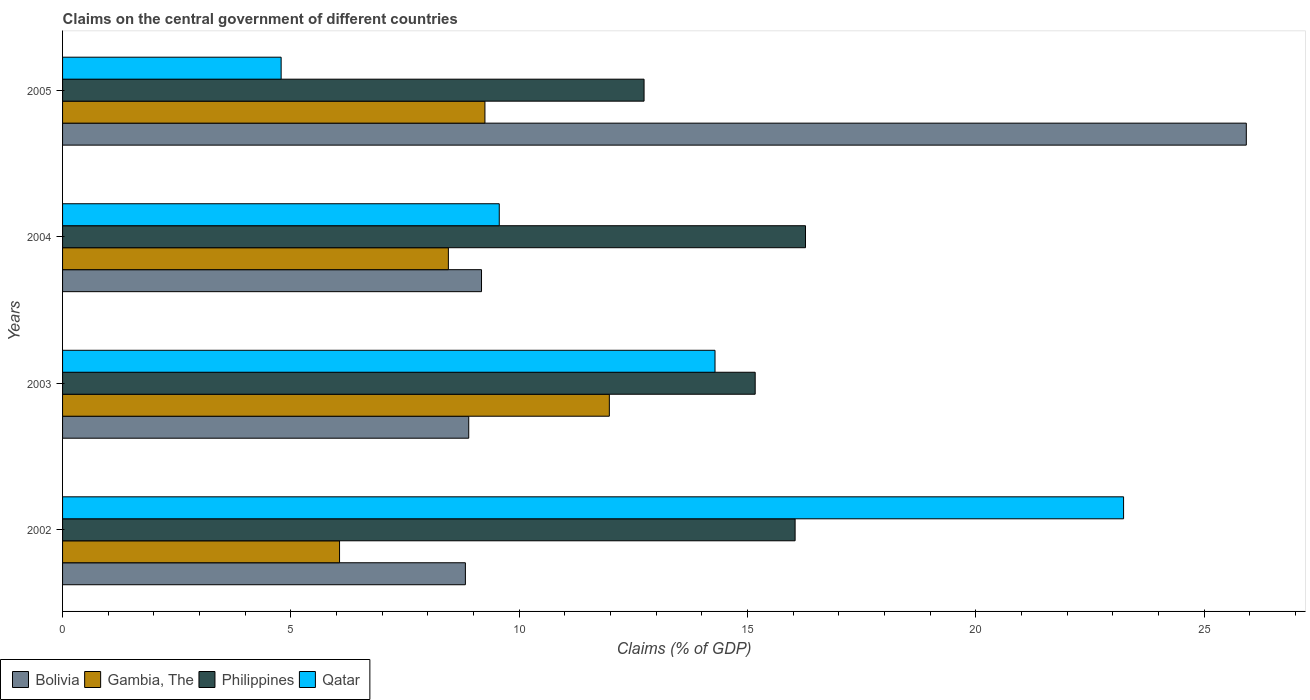How many different coloured bars are there?
Give a very brief answer. 4. Are the number of bars per tick equal to the number of legend labels?
Your answer should be compact. Yes. What is the label of the 3rd group of bars from the top?
Provide a succinct answer. 2003. In how many cases, is the number of bars for a given year not equal to the number of legend labels?
Make the answer very short. 0. What is the percentage of GDP claimed on the central government in Bolivia in 2005?
Keep it short and to the point. 25.92. Across all years, what is the maximum percentage of GDP claimed on the central government in Qatar?
Offer a very short reply. 23.23. Across all years, what is the minimum percentage of GDP claimed on the central government in Gambia, The?
Your answer should be compact. 6.07. In which year was the percentage of GDP claimed on the central government in Philippines maximum?
Provide a short and direct response. 2004. What is the total percentage of GDP claimed on the central government in Bolivia in the graph?
Ensure brevity in your answer.  52.81. What is the difference between the percentage of GDP claimed on the central government in Philippines in 2002 and that in 2005?
Make the answer very short. 3.31. What is the difference between the percentage of GDP claimed on the central government in Gambia, The in 2003 and the percentage of GDP claimed on the central government in Philippines in 2002?
Offer a very short reply. -4.07. What is the average percentage of GDP claimed on the central government in Bolivia per year?
Offer a terse response. 13.2. In the year 2005, what is the difference between the percentage of GDP claimed on the central government in Qatar and percentage of GDP claimed on the central government in Philippines?
Keep it short and to the point. -7.95. In how many years, is the percentage of GDP claimed on the central government in Gambia, The greater than 3 %?
Keep it short and to the point. 4. What is the ratio of the percentage of GDP claimed on the central government in Qatar in 2002 to that in 2004?
Offer a terse response. 2.43. What is the difference between the highest and the second highest percentage of GDP claimed on the central government in Gambia, The?
Offer a very short reply. 2.72. What is the difference between the highest and the lowest percentage of GDP claimed on the central government in Bolivia?
Your answer should be very brief. 17.1. Is the sum of the percentage of GDP claimed on the central government in Gambia, The in 2003 and 2005 greater than the maximum percentage of GDP claimed on the central government in Philippines across all years?
Make the answer very short. Yes. What does the 3rd bar from the top in 2005 represents?
Offer a very short reply. Gambia, The. How many bars are there?
Make the answer very short. 16. Are all the bars in the graph horizontal?
Offer a very short reply. Yes. Are the values on the major ticks of X-axis written in scientific E-notation?
Ensure brevity in your answer.  No. Does the graph contain any zero values?
Provide a short and direct response. No. Does the graph contain grids?
Give a very brief answer. No. Where does the legend appear in the graph?
Make the answer very short. Bottom left. What is the title of the graph?
Give a very brief answer. Claims on the central government of different countries. Does "Japan" appear as one of the legend labels in the graph?
Your answer should be very brief. No. What is the label or title of the X-axis?
Your response must be concise. Claims (% of GDP). What is the label or title of the Y-axis?
Make the answer very short. Years. What is the Claims (% of GDP) in Bolivia in 2002?
Provide a short and direct response. 8.82. What is the Claims (% of GDP) in Gambia, The in 2002?
Your answer should be compact. 6.07. What is the Claims (% of GDP) in Philippines in 2002?
Your answer should be very brief. 16.04. What is the Claims (% of GDP) in Qatar in 2002?
Give a very brief answer. 23.23. What is the Claims (% of GDP) in Bolivia in 2003?
Keep it short and to the point. 8.89. What is the Claims (% of GDP) of Gambia, The in 2003?
Your answer should be compact. 11.97. What is the Claims (% of GDP) in Philippines in 2003?
Keep it short and to the point. 15.17. What is the Claims (% of GDP) of Qatar in 2003?
Your answer should be compact. 14.29. What is the Claims (% of GDP) in Bolivia in 2004?
Provide a short and direct response. 9.17. What is the Claims (% of GDP) of Gambia, The in 2004?
Your answer should be very brief. 8.45. What is the Claims (% of GDP) of Philippines in 2004?
Provide a short and direct response. 16.27. What is the Claims (% of GDP) of Qatar in 2004?
Provide a short and direct response. 9.56. What is the Claims (% of GDP) of Bolivia in 2005?
Your answer should be very brief. 25.92. What is the Claims (% of GDP) of Gambia, The in 2005?
Make the answer very short. 9.25. What is the Claims (% of GDP) in Philippines in 2005?
Offer a terse response. 12.73. What is the Claims (% of GDP) of Qatar in 2005?
Provide a short and direct response. 4.79. Across all years, what is the maximum Claims (% of GDP) of Bolivia?
Your answer should be compact. 25.92. Across all years, what is the maximum Claims (% of GDP) of Gambia, The?
Your answer should be compact. 11.97. Across all years, what is the maximum Claims (% of GDP) in Philippines?
Your answer should be compact. 16.27. Across all years, what is the maximum Claims (% of GDP) in Qatar?
Your response must be concise. 23.23. Across all years, what is the minimum Claims (% of GDP) of Bolivia?
Give a very brief answer. 8.82. Across all years, what is the minimum Claims (% of GDP) in Gambia, The?
Offer a terse response. 6.07. Across all years, what is the minimum Claims (% of GDP) in Philippines?
Provide a short and direct response. 12.73. Across all years, what is the minimum Claims (% of GDP) of Qatar?
Make the answer very short. 4.79. What is the total Claims (% of GDP) in Bolivia in the graph?
Your answer should be compact. 52.81. What is the total Claims (% of GDP) in Gambia, The in the graph?
Your response must be concise. 35.74. What is the total Claims (% of GDP) of Philippines in the graph?
Ensure brevity in your answer.  60.21. What is the total Claims (% of GDP) in Qatar in the graph?
Your answer should be very brief. 51.87. What is the difference between the Claims (% of GDP) in Bolivia in 2002 and that in 2003?
Your answer should be very brief. -0.07. What is the difference between the Claims (% of GDP) in Gambia, The in 2002 and that in 2003?
Provide a short and direct response. -5.91. What is the difference between the Claims (% of GDP) of Philippines in 2002 and that in 2003?
Provide a succinct answer. 0.87. What is the difference between the Claims (% of GDP) of Qatar in 2002 and that in 2003?
Keep it short and to the point. 8.95. What is the difference between the Claims (% of GDP) of Bolivia in 2002 and that in 2004?
Provide a succinct answer. -0.35. What is the difference between the Claims (% of GDP) in Gambia, The in 2002 and that in 2004?
Make the answer very short. -2.38. What is the difference between the Claims (% of GDP) in Philippines in 2002 and that in 2004?
Provide a succinct answer. -0.23. What is the difference between the Claims (% of GDP) of Qatar in 2002 and that in 2004?
Make the answer very short. 13.67. What is the difference between the Claims (% of GDP) of Bolivia in 2002 and that in 2005?
Provide a succinct answer. -17.1. What is the difference between the Claims (% of GDP) of Gambia, The in 2002 and that in 2005?
Provide a succinct answer. -3.18. What is the difference between the Claims (% of GDP) in Philippines in 2002 and that in 2005?
Keep it short and to the point. 3.31. What is the difference between the Claims (% of GDP) in Qatar in 2002 and that in 2005?
Ensure brevity in your answer.  18.45. What is the difference between the Claims (% of GDP) of Bolivia in 2003 and that in 2004?
Provide a succinct answer. -0.28. What is the difference between the Claims (% of GDP) of Gambia, The in 2003 and that in 2004?
Make the answer very short. 3.52. What is the difference between the Claims (% of GDP) in Philippines in 2003 and that in 2004?
Your response must be concise. -1.1. What is the difference between the Claims (% of GDP) of Qatar in 2003 and that in 2004?
Give a very brief answer. 4.72. What is the difference between the Claims (% of GDP) in Bolivia in 2003 and that in 2005?
Your response must be concise. -17.03. What is the difference between the Claims (% of GDP) in Gambia, The in 2003 and that in 2005?
Your answer should be compact. 2.72. What is the difference between the Claims (% of GDP) of Philippines in 2003 and that in 2005?
Your answer should be compact. 2.43. What is the difference between the Claims (% of GDP) of Qatar in 2003 and that in 2005?
Make the answer very short. 9.5. What is the difference between the Claims (% of GDP) in Bolivia in 2004 and that in 2005?
Your response must be concise. -16.75. What is the difference between the Claims (% of GDP) of Gambia, The in 2004 and that in 2005?
Give a very brief answer. -0.8. What is the difference between the Claims (% of GDP) of Philippines in 2004 and that in 2005?
Ensure brevity in your answer.  3.53. What is the difference between the Claims (% of GDP) of Qatar in 2004 and that in 2005?
Offer a terse response. 4.78. What is the difference between the Claims (% of GDP) in Bolivia in 2002 and the Claims (% of GDP) in Gambia, The in 2003?
Make the answer very short. -3.15. What is the difference between the Claims (% of GDP) in Bolivia in 2002 and the Claims (% of GDP) in Philippines in 2003?
Your answer should be very brief. -6.35. What is the difference between the Claims (% of GDP) of Bolivia in 2002 and the Claims (% of GDP) of Qatar in 2003?
Ensure brevity in your answer.  -5.47. What is the difference between the Claims (% of GDP) in Gambia, The in 2002 and the Claims (% of GDP) in Philippines in 2003?
Your response must be concise. -9.1. What is the difference between the Claims (% of GDP) of Gambia, The in 2002 and the Claims (% of GDP) of Qatar in 2003?
Make the answer very short. -8.22. What is the difference between the Claims (% of GDP) in Philippines in 2002 and the Claims (% of GDP) in Qatar in 2003?
Provide a short and direct response. 1.75. What is the difference between the Claims (% of GDP) in Bolivia in 2002 and the Claims (% of GDP) in Gambia, The in 2004?
Your response must be concise. 0.37. What is the difference between the Claims (% of GDP) of Bolivia in 2002 and the Claims (% of GDP) of Philippines in 2004?
Make the answer very short. -7.45. What is the difference between the Claims (% of GDP) of Bolivia in 2002 and the Claims (% of GDP) of Qatar in 2004?
Your answer should be compact. -0.74. What is the difference between the Claims (% of GDP) in Gambia, The in 2002 and the Claims (% of GDP) in Philippines in 2004?
Make the answer very short. -10.2. What is the difference between the Claims (% of GDP) of Gambia, The in 2002 and the Claims (% of GDP) of Qatar in 2004?
Ensure brevity in your answer.  -3.5. What is the difference between the Claims (% of GDP) in Philippines in 2002 and the Claims (% of GDP) in Qatar in 2004?
Your answer should be very brief. 6.48. What is the difference between the Claims (% of GDP) of Bolivia in 2002 and the Claims (% of GDP) of Gambia, The in 2005?
Your answer should be very brief. -0.43. What is the difference between the Claims (% of GDP) in Bolivia in 2002 and the Claims (% of GDP) in Philippines in 2005?
Your answer should be compact. -3.91. What is the difference between the Claims (% of GDP) in Bolivia in 2002 and the Claims (% of GDP) in Qatar in 2005?
Offer a very short reply. 4.03. What is the difference between the Claims (% of GDP) in Gambia, The in 2002 and the Claims (% of GDP) in Philippines in 2005?
Offer a very short reply. -6.67. What is the difference between the Claims (% of GDP) of Gambia, The in 2002 and the Claims (% of GDP) of Qatar in 2005?
Provide a succinct answer. 1.28. What is the difference between the Claims (% of GDP) of Philippines in 2002 and the Claims (% of GDP) of Qatar in 2005?
Your answer should be very brief. 11.25. What is the difference between the Claims (% of GDP) of Bolivia in 2003 and the Claims (% of GDP) of Gambia, The in 2004?
Provide a short and direct response. 0.45. What is the difference between the Claims (% of GDP) of Bolivia in 2003 and the Claims (% of GDP) of Philippines in 2004?
Keep it short and to the point. -7.37. What is the difference between the Claims (% of GDP) in Bolivia in 2003 and the Claims (% of GDP) in Qatar in 2004?
Provide a succinct answer. -0.67. What is the difference between the Claims (% of GDP) in Gambia, The in 2003 and the Claims (% of GDP) in Philippines in 2004?
Offer a terse response. -4.3. What is the difference between the Claims (% of GDP) in Gambia, The in 2003 and the Claims (% of GDP) in Qatar in 2004?
Your answer should be compact. 2.41. What is the difference between the Claims (% of GDP) of Philippines in 2003 and the Claims (% of GDP) of Qatar in 2004?
Your answer should be compact. 5.6. What is the difference between the Claims (% of GDP) of Bolivia in 2003 and the Claims (% of GDP) of Gambia, The in 2005?
Make the answer very short. -0.35. What is the difference between the Claims (% of GDP) in Bolivia in 2003 and the Claims (% of GDP) in Philippines in 2005?
Ensure brevity in your answer.  -3.84. What is the difference between the Claims (% of GDP) in Bolivia in 2003 and the Claims (% of GDP) in Qatar in 2005?
Provide a succinct answer. 4.11. What is the difference between the Claims (% of GDP) of Gambia, The in 2003 and the Claims (% of GDP) of Philippines in 2005?
Keep it short and to the point. -0.76. What is the difference between the Claims (% of GDP) of Gambia, The in 2003 and the Claims (% of GDP) of Qatar in 2005?
Provide a succinct answer. 7.19. What is the difference between the Claims (% of GDP) in Philippines in 2003 and the Claims (% of GDP) in Qatar in 2005?
Keep it short and to the point. 10.38. What is the difference between the Claims (% of GDP) in Bolivia in 2004 and the Claims (% of GDP) in Gambia, The in 2005?
Offer a very short reply. -0.08. What is the difference between the Claims (% of GDP) of Bolivia in 2004 and the Claims (% of GDP) of Philippines in 2005?
Make the answer very short. -3.56. What is the difference between the Claims (% of GDP) of Bolivia in 2004 and the Claims (% of GDP) of Qatar in 2005?
Provide a short and direct response. 4.39. What is the difference between the Claims (% of GDP) in Gambia, The in 2004 and the Claims (% of GDP) in Philippines in 2005?
Your response must be concise. -4.29. What is the difference between the Claims (% of GDP) in Gambia, The in 2004 and the Claims (% of GDP) in Qatar in 2005?
Give a very brief answer. 3.66. What is the difference between the Claims (% of GDP) of Philippines in 2004 and the Claims (% of GDP) of Qatar in 2005?
Offer a terse response. 11.48. What is the average Claims (% of GDP) in Bolivia per year?
Provide a short and direct response. 13.2. What is the average Claims (% of GDP) in Gambia, The per year?
Your answer should be very brief. 8.93. What is the average Claims (% of GDP) of Philippines per year?
Your answer should be very brief. 15.05. What is the average Claims (% of GDP) of Qatar per year?
Ensure brevity in your answer.  12.97. In the year 2002, what is the difference between the Claims (% of GDP) in Bolivia and Claims (% of GDP) in Gambia, The?
Ensure brevity in your answer.  2.76. In the year 2002, what is the difference between the Claims (% of GDP) in Bolivia and Claims (% of GDP) in Philippines?
Give a very brief answer. -7.22. In the year 2002, what is the difference between the Claims (% of GDP) of Bolivia and Claims (% of GDP) of Qatar?
Offer a very short reply. -14.41. In the year 2002, what is the difference between the Claims (% of GDP) in Gambia, The and Claims (% of GDP) in Philippines?
Make the answer very short. -9.98. In the year 2002, what is the difference between the Claims (% of GDP) in Gambia, The and Claims (% of GDP) in Qatar?
Ensure brevity in your answer.  -17.17. In the year 2002, what is the difference between the Claims (% of GDP) in Philippines and Claims (% of GDP) in Qatar?
Keep it short and to the point. -7.19. In the year 2003, what is the difference between the Claims (% of GDP) in Bolivia and Claims (% of GDP) in Gambia, The?
Offer a terse response. -3.08. In the year 2003, what is the difference between the Claims (% of GDP) of Bolivia and Claims (% of GDP) of Philippines?
Provide a short and direct response. -6.27. In the year 2003, what is the difference between the Claims (% of GDP) in Bolivia and Claims (% of GDP) in Qatar?
Your answer should be very brief. -5.39. In the year 2003, what is the difference between the Claims (% of GDP) of Gambia, The and Claims (% of GDP) of Philippines?
Offer a terse response. -3.19. In the year 2003, what is the difference between the Claims (% of GDP) of Gambia, The and Claims (% of GDP) of Qatar?
Keep it short and to the point. -2.31. In the year 2003, what is the difference between the Claims (% of GDP) of Philippines and Claims (% of GDP) of Qatar?
Keep it short and to the point. 0.88. In the year 2004, what is the difference between the Claims (% of GDP) of Bolivia and Claims (% of GDP) of Gambia, The?
Keep it short and to the point. 0.73. In the year 2004, what is the difference between the Claims (% of GDP) of Bolivia and Claims (% of GDP) of Philippines?
Make the answer very short. -7.09. In the year 2004, what is the difference between the Claims (% of GDP) in Bolivia and Claims (% of GDP) in Qatar?
Provide a succinct answer. -0.39. In the year 2004, what is the difference between the Claims (% of GDP) of Gambia, The and Claims (% of GDP) of Philippines?
Give a very brief answer. -7.82. In the year 2004, what is the difference between the Claims (% of GDP) of Gambia, The and Claims (% of GDP) of Qatar?
Give a very brief answer. -1.11. In the year 2004, what is the difference between the Claims (% of GDP) of Philippines and Claims (% of GDP) of Qatar?
Ensure brevity in your answer.  6.71. In the year 2005, what is the difference between the Claims (% of GDP) in Bolivia and Claims (% of GDP) in Gambia, The?
Ensure brevity in your answer.  16.67. In the year 2005, what is the difference between the Claims (% of GDP) in Bolivia and Claims (% of GDP) in Philippines?
Your response must be concise. 13.19. In the year 2005, what is the difference between the Claims (% of GDP) in Bolivia and Claims (% of GDP) in Qatar?
Give a very brief answer. 21.13. In the year 2005, what is the difference between the Claims (% of GDP) in Gambia, The and Claims (% of GDP) in Philippines?
Your answer should be very brief. -3.48. In the year 2005, what is the difference between the Claims (% of GDP) of Gambia, The and Claims (% of GDP) of Qatar?
Provide a succinct answer. 4.46. In the year 2005, what is the difference between the Claims (% of GDP) in Philippines and Claims (% of GDP) in Qatar?
Offer a terse response. 7.95. What is the ratio of the Claims (% of GDP) of Bolivia in 2002 to that in 2003?
Keep it short and to the point. 0.99. What is the ratio of the Claims (% of GDP) of Gambia, The in 2002 to that in 2003?
Your response must be concise. 0.51. What is the ratio of the Claims (% of GDP) of Philippines in 2002 to that in 2003?
Your answer should be very brief. 1.06. What is the ratio of the Claims (% of GDP) of Qatar in 2002 to that in 2003?
Give a very brief answer. 1.63. What is the ratio of the Claims (% of GDP) of Bolivia in 2002 to that in 2004?
Your answer should be compact. 0.96. What is the ratio of the Claims (% of GDP) in Gambia, The in 2002 to that in 2004?
Your answer should be very brief. 0.72. What is the ratio of the Claims (% of GDP) in Philippines in 2002 to that in 2004?
Your answer should be compact. 0.99. What is the ratio of the Claims (% of GDP) in Qatar in 2002 to that in 2004?
Give a very brief answer. 2.43. What is the ratio of the Claims (% of GDP) in Bolivia in 2002 to that in 2005?
Provide a succinct answer. 0.34. What is the ratio of the Claims (% of GDP) in Gambia, The in 2002 to that in 2005?
Offer a terse response. 0.66. What is the ratio of the Claims (% of GDP) of Philippines in 2002 to that in 2005?
Your answer should be very brief. 1.26. What is the ratio of the Claims (% of GDP) of Qatar in 2002 to that in 2005?
Your answer should be very brief. 4.85. What is the ratio of the Claims (% of GDP) of Bolivia in 2003 to that in 2004?
Your response must be concise. 0.97. What is the ratio of the Claims (% of GDP) in Gambia, The in 2003 to that in 2004?
Your answer should be compact. 1.42. What is the ratio of the Claims (% of GDP) of Philippines in 2003 to that in 2004?
Provide a short and direct response. 0.93. What is the ratio of the Claims (% of GDP) in Qatar in 2003 to that in 2004?
Offer a terse response. 1.49. What is the ratio of the Claims (% of GDP) in Bolivia in 2003 to that in 2005?
Keep it short and to the point. 0.34. What is the ratio of the Claims (% of GDP) in Gambia, The in 2003 to that in 2005?
Offer a very short reply. 1.29. What is the ratio of the Claims (% of GDP) in Philippines in 2003 to that in 2005?
Ensure brevity in your answer.  1.19. What is the ratio of the Claims (% of GDP) in Qatar in 2003 to that in 2005?
Keep it short and to the point. 2.98. What is the ratio of the Claims (% of GDP) of Bolivia in 2004 to that in 2005?
Offer a very short reply. 0.35. What is the ratio of the Claims (% of GDP) of Gambia, The in 2004 to that in 2005?
Offer a very short reply. 0.91. What is the ratio of the Claims (% of GDP) in Philippines in 2004 to that in 2005?
Make the answer very short. 1.28. What is the ratio of the Claims (% of GDP) of Qatar in 2004 to that in 2005?
Your answer should be compact. 2. What is the difference between the highest and the second highest Claims (% of GDP) in Bolivia?
Give a very brief answer. 16.75. What is the difference between the highest and the second highest Claims (% of GDP) in Gambia, The?
Give a very brief answer. 2.72. What is the difference between the highest and the second highest Claims (% of GDP) in Philippines?
Offer a very short reply. 0.23. What is the difference between the highest and the second highest Claims (% of GDP) in Qatar?
Keep it short and to the point. 8.95. What is the difference between the highest and the lowest Claims (% of GDP) in Bolivia?
Give a very brief answer. 17.1. What is the difference between the highest and the lowest Claims (% of GDP) in Gambia, The?
Keep it short and to the point. 5.91. What is the difference between the highest and the lowest Claims (% of GDP) of Philippines?
Keep it short and to the point. 3.53. What is the difference between the highest and the lowest Claims (% of GDP) of Qatar?
Your answer should be very brief. 18.45. 